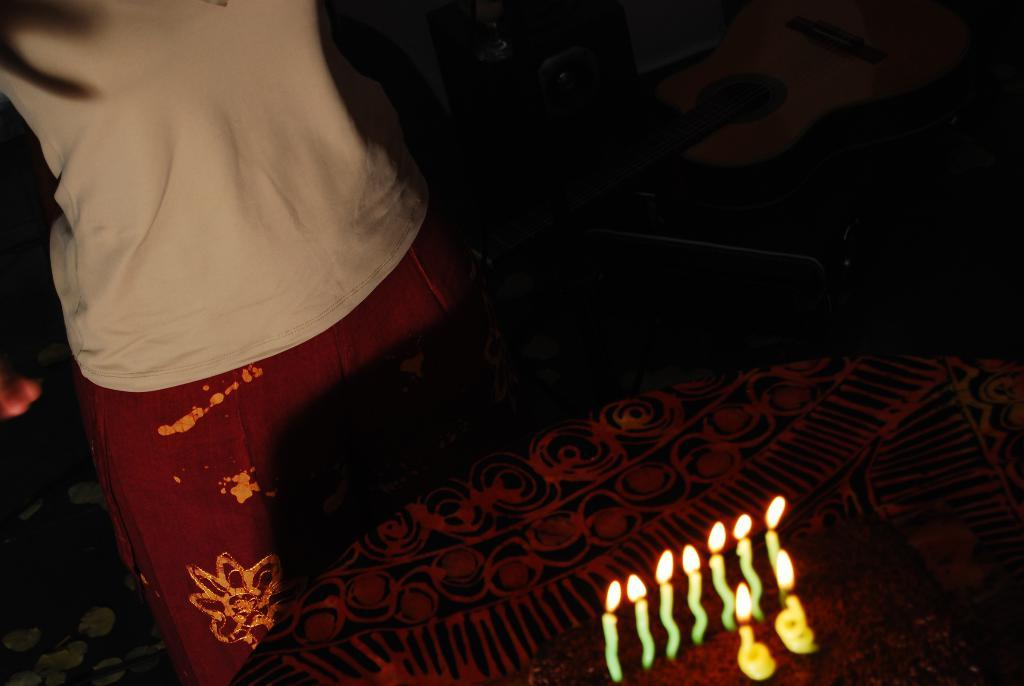What piece of furniture is present in the image? There is a table in the image. What is placed on the table? There is a cake on the table. What is on top of the cake? There are candles on the cake. Who is present in the image? There is a person standing in the image. What can be observed about the lighting in the image? The background of the image is dark. Can you see the partner of the person standing in the image? There is no partner present in the image; only one person is standing. What type of harbor can be seen in the background of the image? There is no harbor present in the image; the background is dark. 